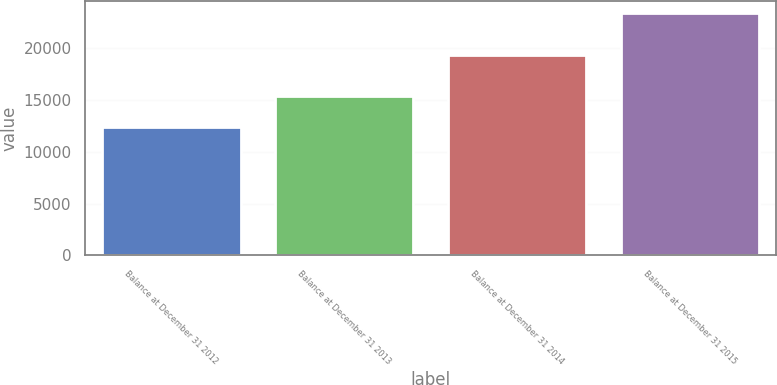<chart> <loc_0><loc_0><loc_500><loc_500><bar_chart><fcel>Balance at December 31 2012<fcel>Balance at December 31 2013<fcel>Balance at December 31 2014<fcel>Balance at December 31 2015<nl><fcel>12407<fcel>15385<fcel>19307<fcel>23308<nl></chart> 